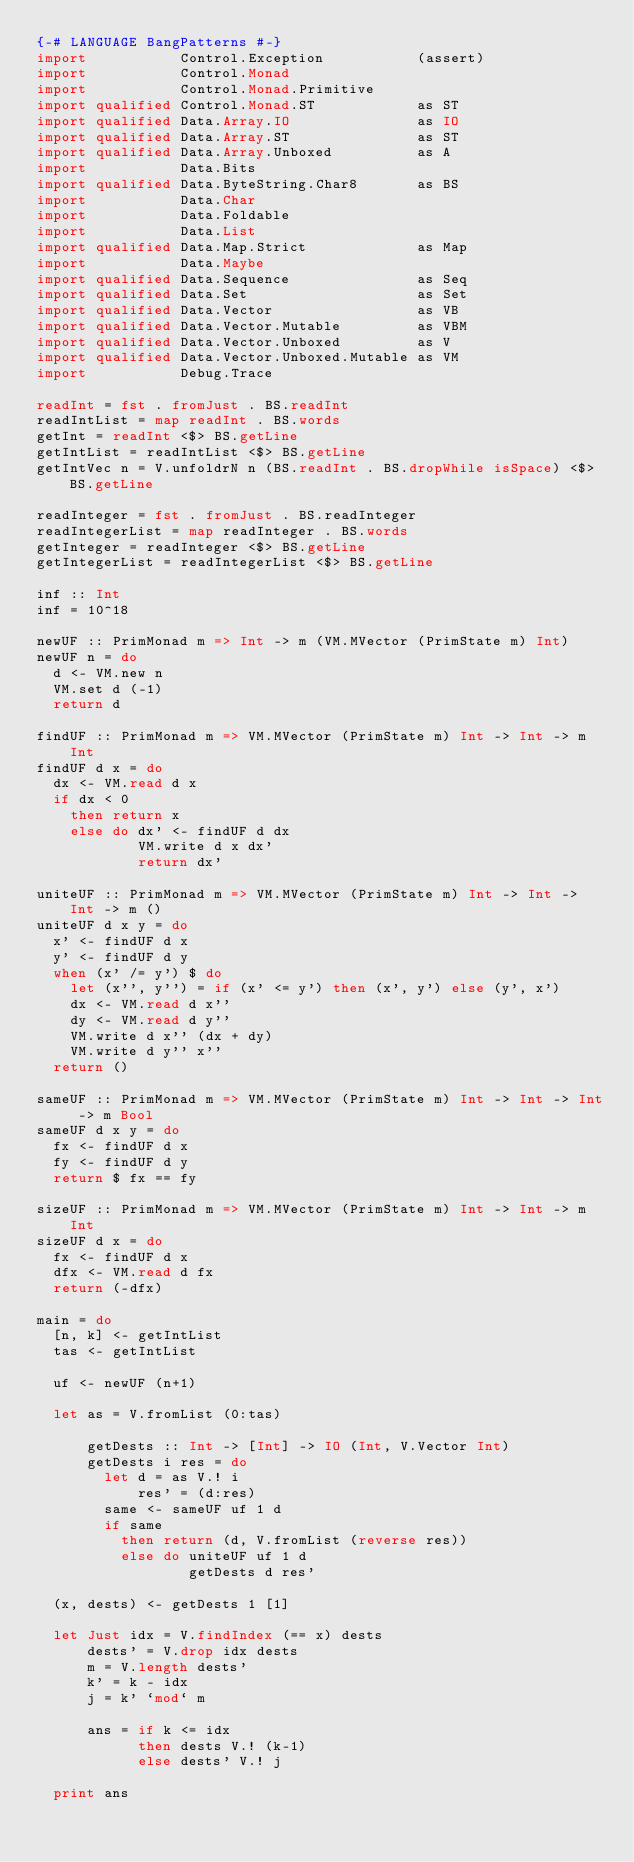<code> <loc_0><loc_0><loc_500><loc_500><_Haskell_>{-# LANGUAGE BangPatterns #-}
import           Control.Exception           (assert)
import           Control.Monad
import           Control.Monad.Primitive
import qualified Control.Monad.ST            as ST
import qualified Data.Array.IO               as IO
import qualified Data.Array.ST               as ST
import qualified Data.Array.Unboxed          as A
import           Data.Bits
import qualified Data.ByteString.Char8       as BS
import           Data.Char
import           Data.Foldable
import           Data.List
import qualified Data.Map.Strict             as Map
import           Data.Maybe
import qualified Data.Sequence               as Seq
import qualified Data.Set                    as Set
import qualified Data.Vector                 as VB
import qualified Data.Vector.Mutable         as VBM
import qualified Data.Vector.Unboxed         as V
import qualified Data.Vector.Unboxed.Mutable as VM
import           Debug.Trace

readInt = fst . fromJust . BS.readInt
readIntList = map readInt . BS.words
getInt = readInt <$> BS.getLine
getIntList = readIntList <$> BS.getLine
getIntVec n = V.unfoldrN n (BS.readInt . BS.dropWhile isSpace) <$> BS.getLine

readInteger = fst . fromJust . BS.readInteger
readIntegerList = map readInteger . BS.words
getInteger = readInteger <$> BS.getLine
getIntegerList = readIntegerList <$> BS.getLine

inf :: Int
inf = 10^18

newUF :: PrimMonad m => Int -> m (VM.MVector (PrimState m) Int)
newUF n = do
  d <- VM.new n
  VM.set d (-1)
  return d

findUF :: PrimMonad m => VM.MVector (PrimState m) Int -> Int -> m Int
findUF d x = do
  dx <- VM.read d x
  if dx < 0
    then return x
    else do dx' <- findUF d dx
            VM.write d x dx'
            return dx'

uniteUF :: PrimMonad m => VM.MVector (PrimState m) Int -> Int -> Int -> m ()
uniteUF d x y = do
  x' <- findUF d x
  y' <- findUF d y
  when (x' /= y') $ do
    let (x'', y'') = if (x' <= y') then (x', y') else (y', x')
    dx <- VM.read d x''
    dy <- VM.read d y''
    VM.write d x'' (dx + dy)
    VM.write d y'' x''
  return ()

sameUF :: PrimMonad m => VM.MVector (PrimState m) Int -> Int -> Int -> m Bool
sameUF d x y = do
  fx <- findUF d x
  fy <- findUF d y
  return $ fx == fy

sizeUF :: PrimMonad m => VM.MVector (PrimState m) Int -> Int -> m Int
sizeUF d x = do
  fx <- findUF d x
  dfx <- VM.read d fx
  return (-dfx)

main = do
  [n, k] <- getIntList
  tas <- getIntList

  uf <- newUF (n+1)

  let as = V.fromList (0:tas)

      getDests :: Int -> [Int] -> IO (Int, V.Vector Int)
      getDests i res = do
        let d = as V.! i
            res' = (d:res)
        same <- sameUF uf 1 d
        if same
          then return (d, V.fromList (reverse res))
          else do uniteUF uf 1 d
                  getDests d res'

  (x, dests) <- getDests 1 [1]

  let Just idx = V.findIndex (== x) dests
      dests' = V.drop idx dests
      m = V.length dests'
      k' = k - idx
      j = k' `mod` m

      ans = if k <= idx
            then dests V.! (k-1)
            else dests' V.! j

  print ans
</code> 